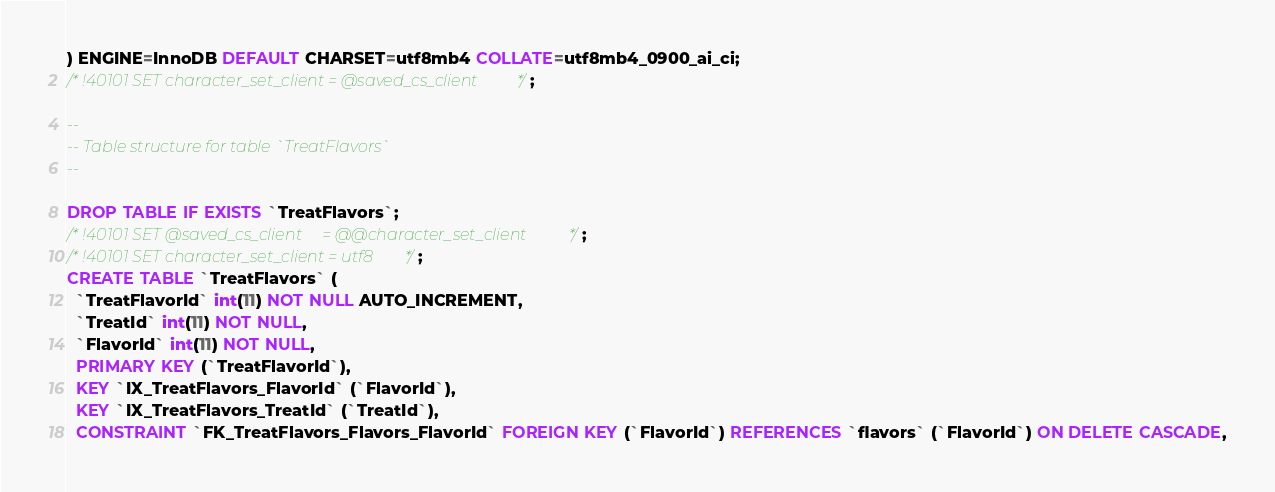Convert code to text. <code><loc_0><loc_0><loc_500><loc_500><_SQL_>) ENGINE=InnoDB DEFAULT CHARSET=utf8mb4 COLLATE=utf8mb4_0900_ai_ci;
/*!40101 SET character_set_client = @saved_cs_client */;

--
-- Table structure for table `TreatFlavors`
--

DROP TABLE IF EXISTS `TreatFlavors`;
/*!40101 SET @saved_cs_client     = @@character_set_client */;
/*!40101 SET character_set_client = utf8 */;
CREATE TABLE `TreatFlavors` (
  `TreatFlavorId` int(11) NOT NULL AUTO_INCREMENT,
  `TreatId` int(11) NOT NULL,
  `FlavorId` int(11) NOT NULL,
  PRIMARY KEY (`TreatFlavorId`),
  KEY `IX_TreatFlavors_FlavorId` (`FlavorId`),
  KEY `IX_TreatFlavors_TreatId` (`TreatId`),
  CONSTRAINT `FK_TreatFlavors_Flavors_FlavorId` FOREIGN KEY (`FlavorId`) REFERENCES `flavors` (`FlavorId`) ON DELETE CASCADE,</code> 